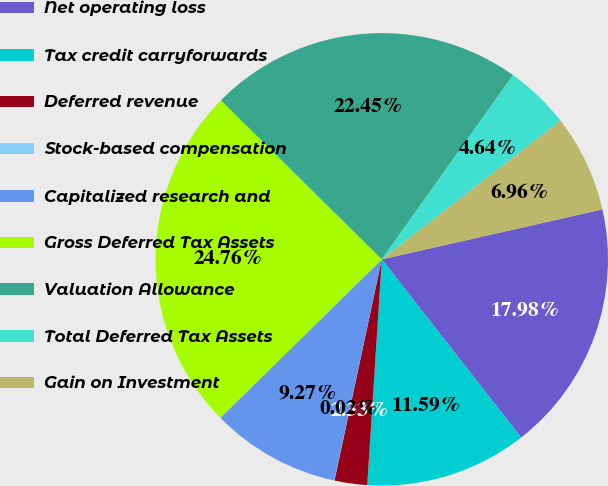Convert chart to OTSL. <chart><loc_0><loc_0><loc_500><loc_500><pie_chart><fcel>Net operating loss<fcel>Tax credit carryforwards<fcel>Deferred revenue<fcel>Stock-based compensation<fcel>Capitalized research and<fcel>Gross Deferred Tax Assets<fcel>Valuation Allowance<fcel>Total Deferred Tax Assets<fcel>Gain on Investment<nl><fcel>17.98%<fcel>11.59%<fcel>2.33%<fcel>0.02%<fcel>9.27%<fcel>24.76%<fcel>22.45%<fcel>4.64%<fcel>6.96%<nl></chart> 